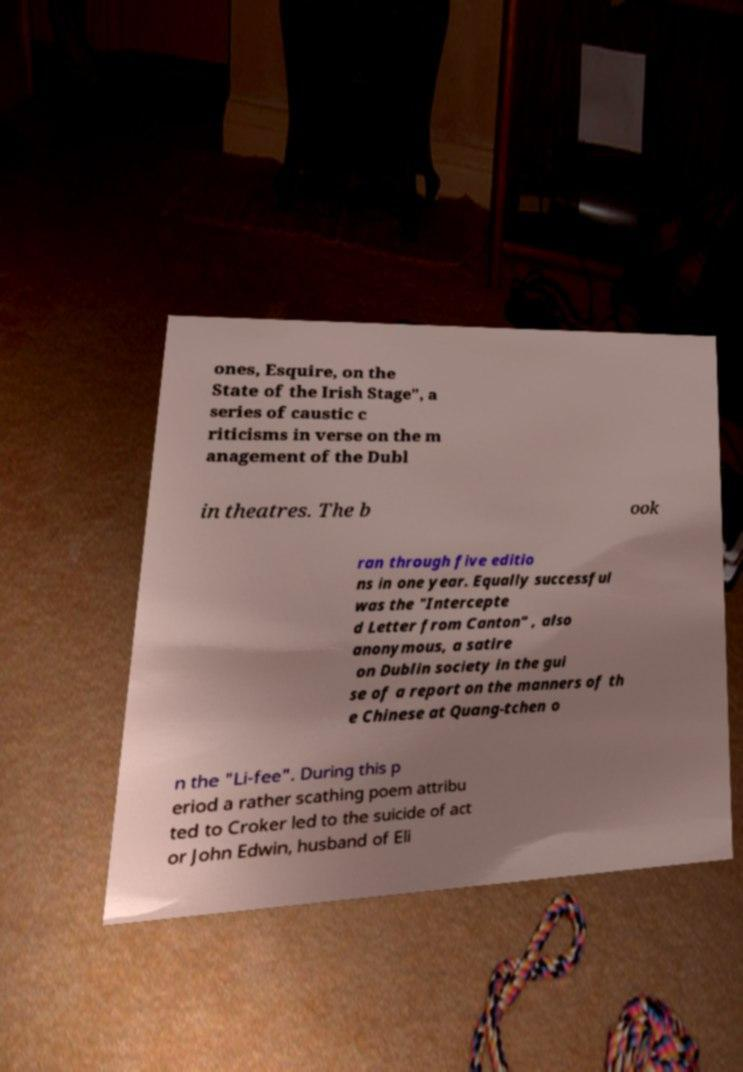Could you assist in decoding the text presented in this image and type it out clearly? ones, Esquire, on the State of the Irish Stage", a series of caustic c riticisms in verse on the m anagement of the Dubl in theatres. The b ook ran through five editio ns in one year. Equally successful was the "Intercepte d Letter from Canton" , also anonymous, a satire on Dublin society in the gui se of a report on the manners of th e Chinese at Quang-tchen o n the "Li-fee". During this p eriod a rather scathing poem attribu ted to Croker led to the suicide of act or John Edwin, husband of Eli 